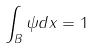<formula> <loc_0><loc_0><loc_500><loc_500>\int _ { B } \psi d x = 1</formula> 